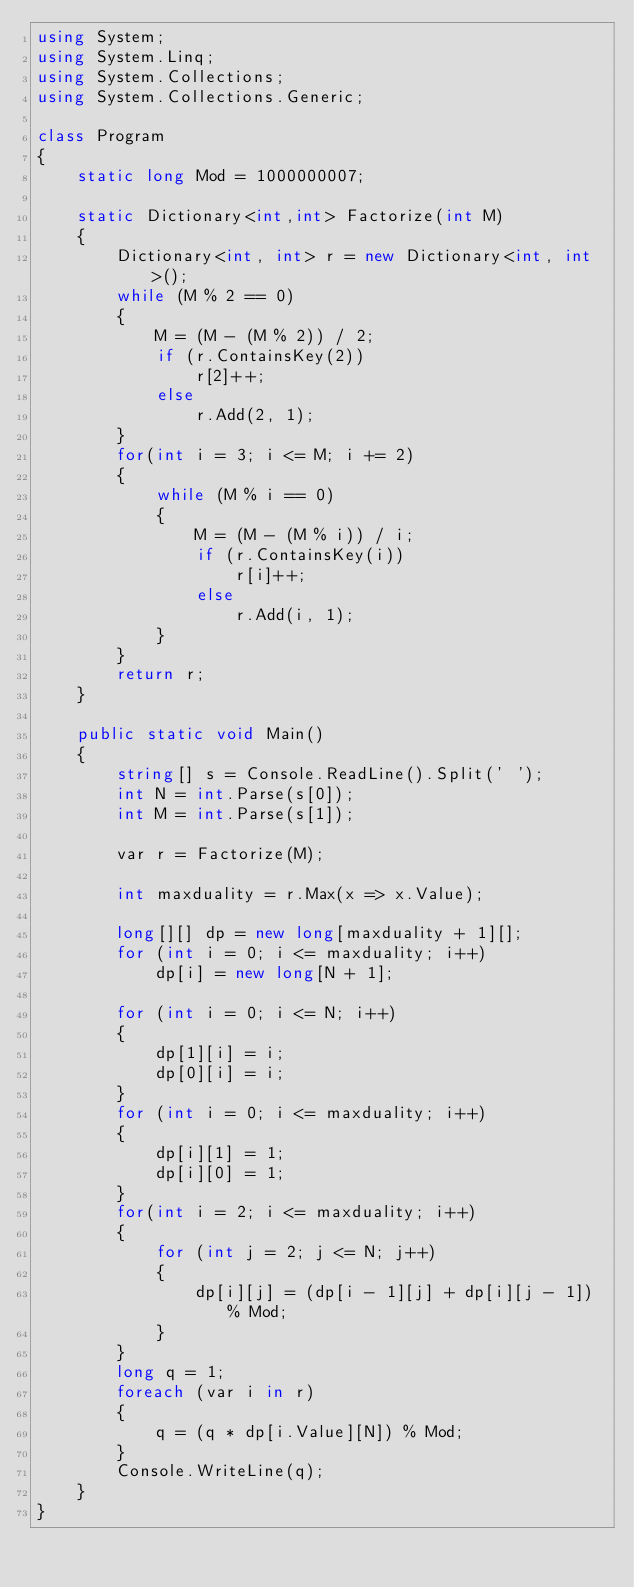<code> <loc_0><loc_0><loc_500><loc_500><_C#_>using System;
using System.Linq;
using System.Collections;
using System.Collections.Generic;

class Program
{
    static long Mod = 1000000007;

    static Dictionary<int,int> Factorize(int M)
    {
        Dictionary<int, int> r = new Dictionary<int, int>();
        while (M % 2 == 0)
        {
            M = (M - (M % 2)) / 2;
            if (r.ContainsKey(2))
                r[2]++;
            else
                r.Add(2, 1);
        }
        for(int i = 3; i <= M; i += 2)
        {
            while (M % i == 0)
            {
                M = (M - (M % i)) / i;
                if (r.ContainsKey(i))
                    r[i]++;
                else
                    r.Add(i, 1);
            }
        }
        return r;
    }
        
    public static void Main()
    {
        string[] s = Console.ReadLine().Split(' ');
        int N = int.Parse(s[0]);
        int M = int.Parse(s[1]);

        var r = Factorize(M);

        int maxduality = r.Max(x => x.Value);

        long[][] dp = new long[maxduality + 1][];
        for (int i = 0; i <= maxduality; i++)
            dp[i] = new long[N + 1];

        for (int i = 0; i <= N; i++)
        {
            dp[1][i] = i;
            dp[0][i] = i;
        }
        for (int i = 0; i <= maxduality; i++)
        {
            dp[i][1] = 1;
            dp[i][0] = 1;
        }
        for(int i = 2; i <= maxduality; i++)
        {
            for (int j = 2; j <= N; j++)
            {
                dp[i][j] = (dp[i - 1][j] + dp[i][j - 1]) % Mod;
            }
        }
        long q = 1;
        foreach (var i in r)
        {
            q = (q * dp[i.Value][N]) % Mod;
        }
        Console.WriteLine(q);
    }
}</code> 